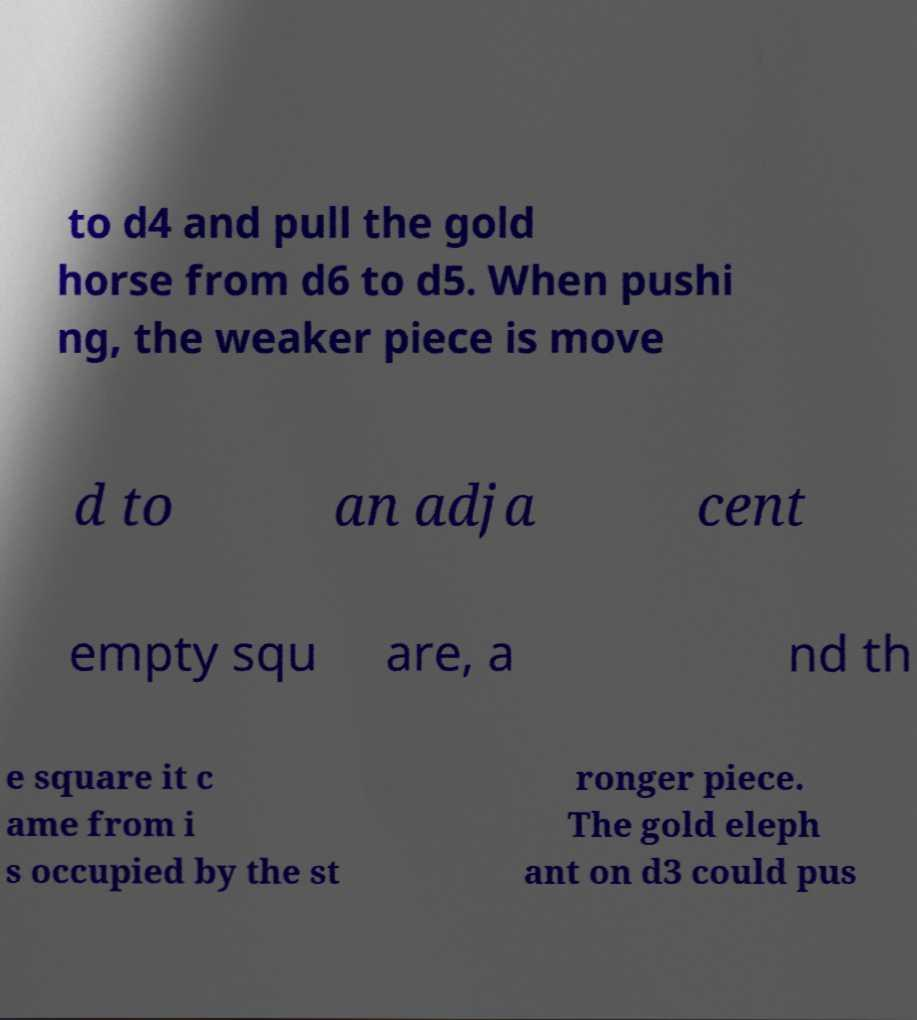What messages or text are displayed in this image? I need them in a readable, typed format. to d4 and pull the gold horse from d6 to d5. When pushi ng, the weaker piece is move d to an adja cent empty squ are, a nd th e square it c ame from i s occupied by the st ronger piece. The gold eleph ant on d3 could pus 